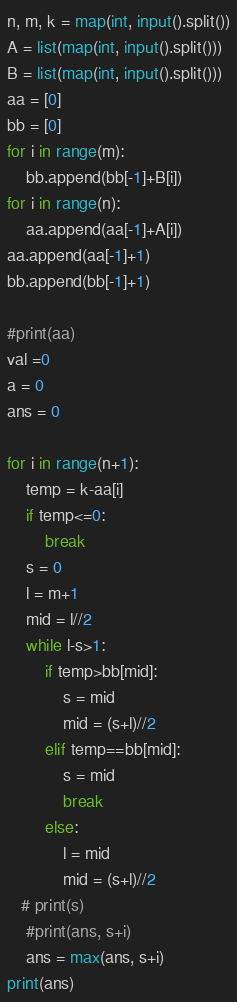Convert code to text. <code><loc_0><loc_0><loc_500><loc_500><_Python_>n, m, k = map(int, input().split())
A = list(map(int, input().split()))
B = list(map(int, input().split()))
aa = [0] 
bb = [0]
for i in range(m):
    bb.append(bb[-1]+B[i])
for i in range(n):
    aa.append(aa[-1]+A[i])
aa.append(aa[-1]+1)
bb.append(bb[-1]+1)

#print(aa)
val =0
a = 0
ans = 0

for i in range(n+1):
    temp = k-aa[i]
    if temp<=0:
        break
    s = 0
    l = m+1
    mid = l//2
    while l-s>1:
        if temp>bb[mid]:
            s = mid
            mid = (s+l)//2
        elif temp==bb[mid]:
            s = mid
            break
        else:
            l = mid
            mid = (s+l)//2
   # print(s)
    #print(ans, s+i)
    ans = max(ans, s+i)
print(ans)</code> 